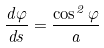<formula> <loc_0><loc_0><loc_500><loc_500>\frac { d \varphi } { d s } = \frac { \cos ^ { 2 } \varphi } { a }</formula> 